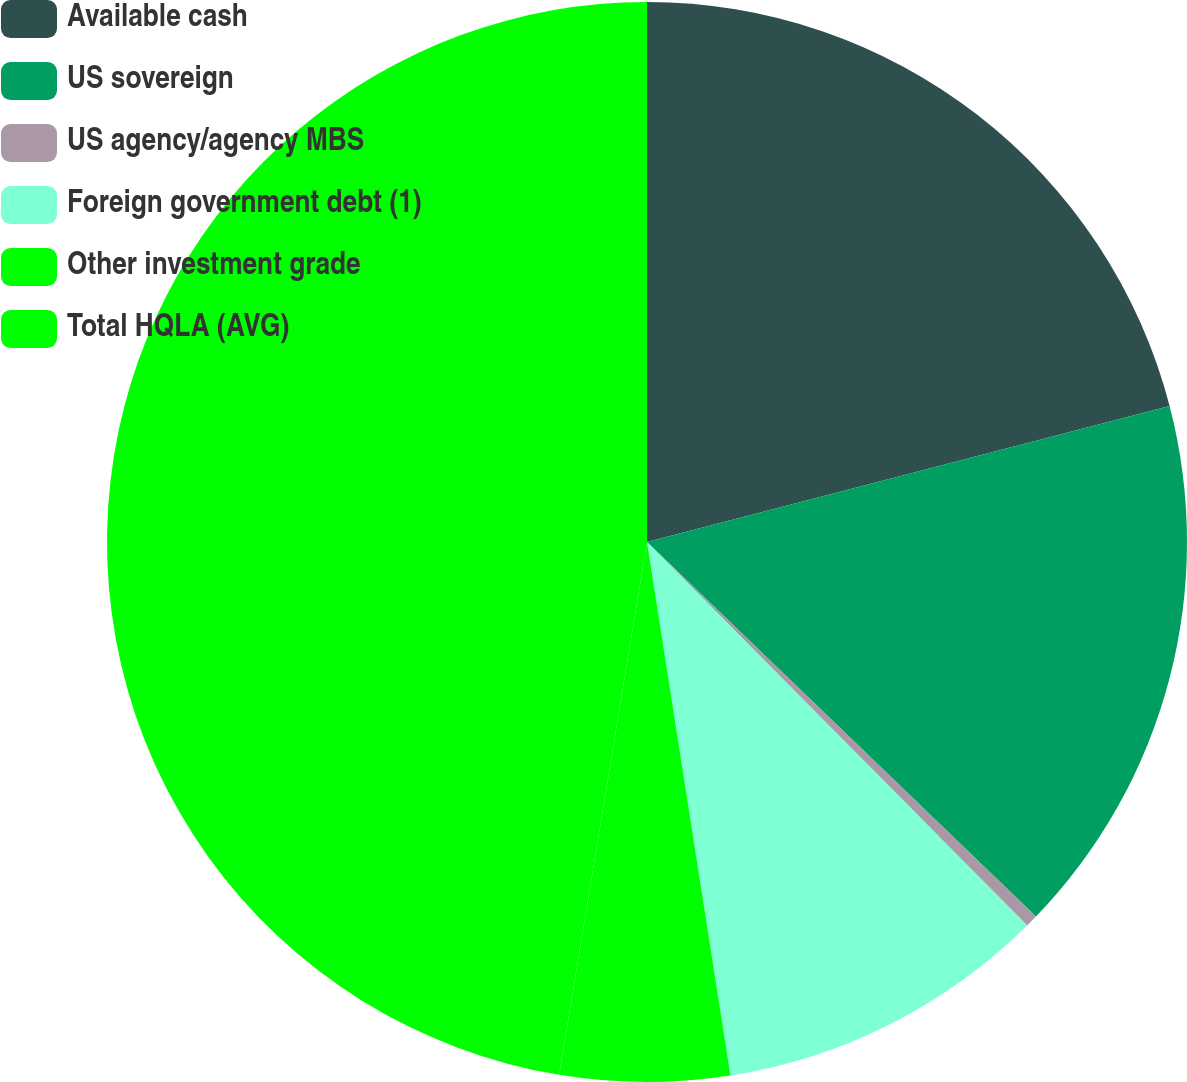<chart> <loc_0><loc_0><loc_500><loc_500><pie_chart><fcel>Available cash<fcel>US sovereign<fcel>US agency/agency MBS<fcel>Foreign government debt (1)<fcel>Other investment grade<fcel>Total HQLA (AVG)<nl><fcel>20.95%<fcel>16.25%<fcel>0.37%<fcel>9.96%<fcel>5.07%<fcel>47.4%<nl></chart> 